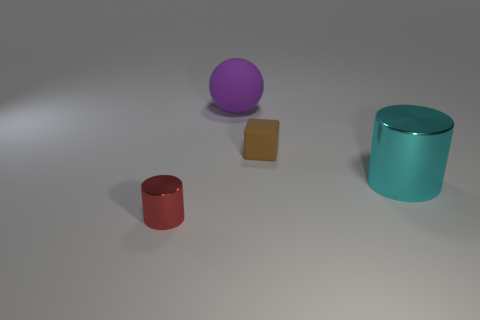Add 3 shiny things. How many objects exist? 7 Subtract all balls. How many objects are left? 3 Subtract all small metallic cylinders. Subtract all red cubes. How many objects are left? 3 Add 2 brown matte objects. How many brown matte objects are left? 3 Add 2 big metal cubes. How many big metal cubes exist? 2 Subtract 0 brown spheres. How many objects are left? 4 